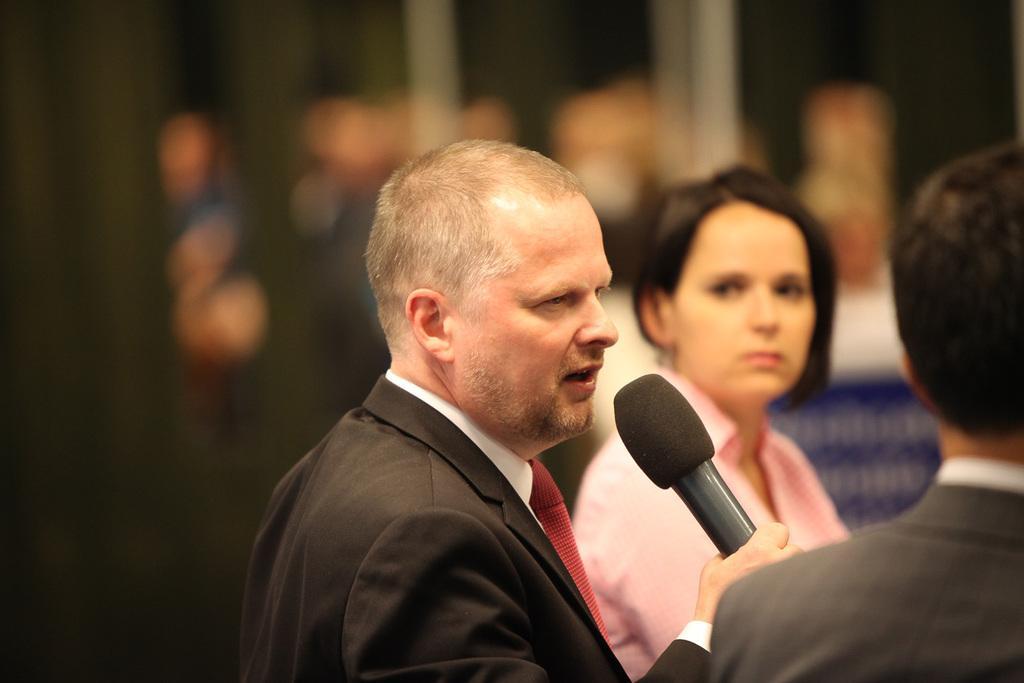Could you give a brief overview of what you see in this image? In the image we see there is a man who is holding a mike and beside him there is a woman and on the other there is another person. 